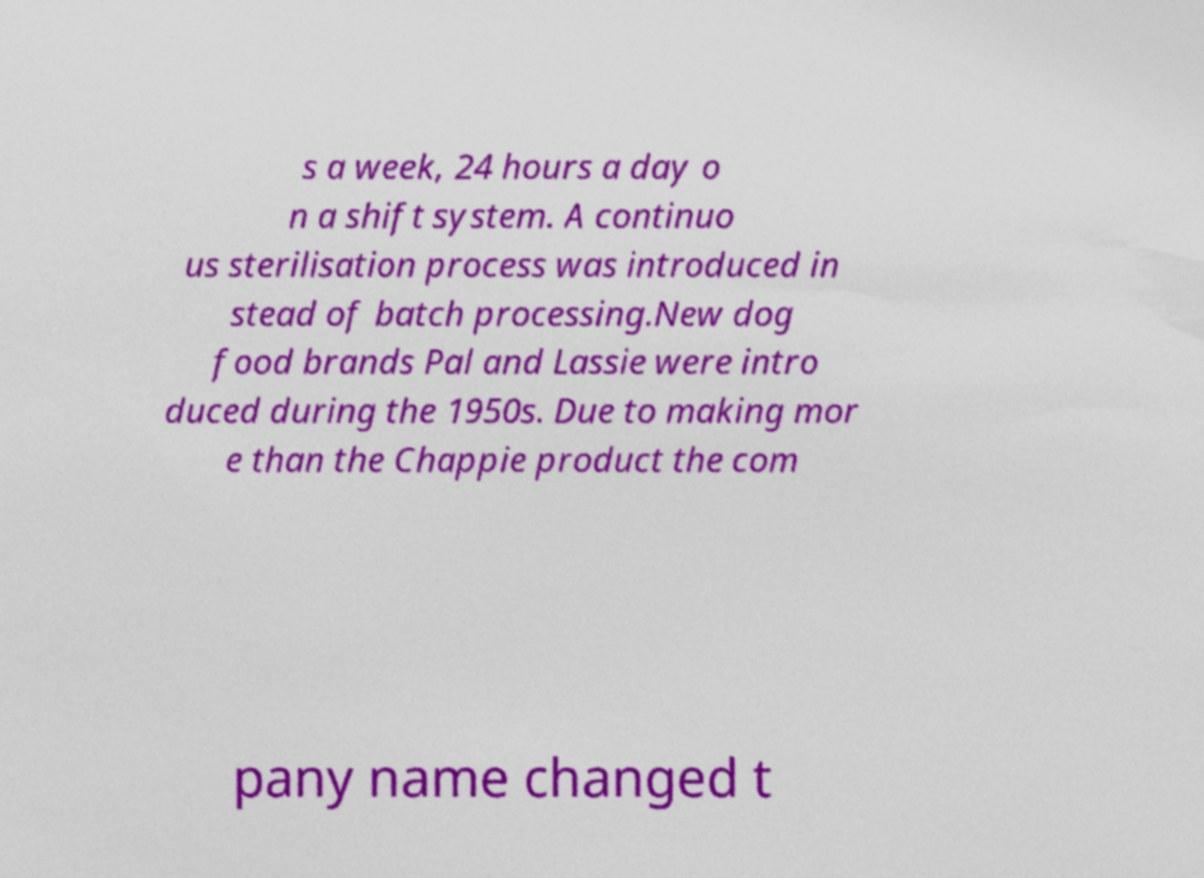Can you read and provide the text displayed in the image?This photo seems to have some interesting text. Can you extract and type it out for me? s a week, 24 hours a day o n a shift system. A continuo us sterilisation process was introduced in stead of batch processing.New dog food brands Pal and Lassie were intro duced during the 1950s. Due to making mor e than the Chappie product the com pany name changed t 